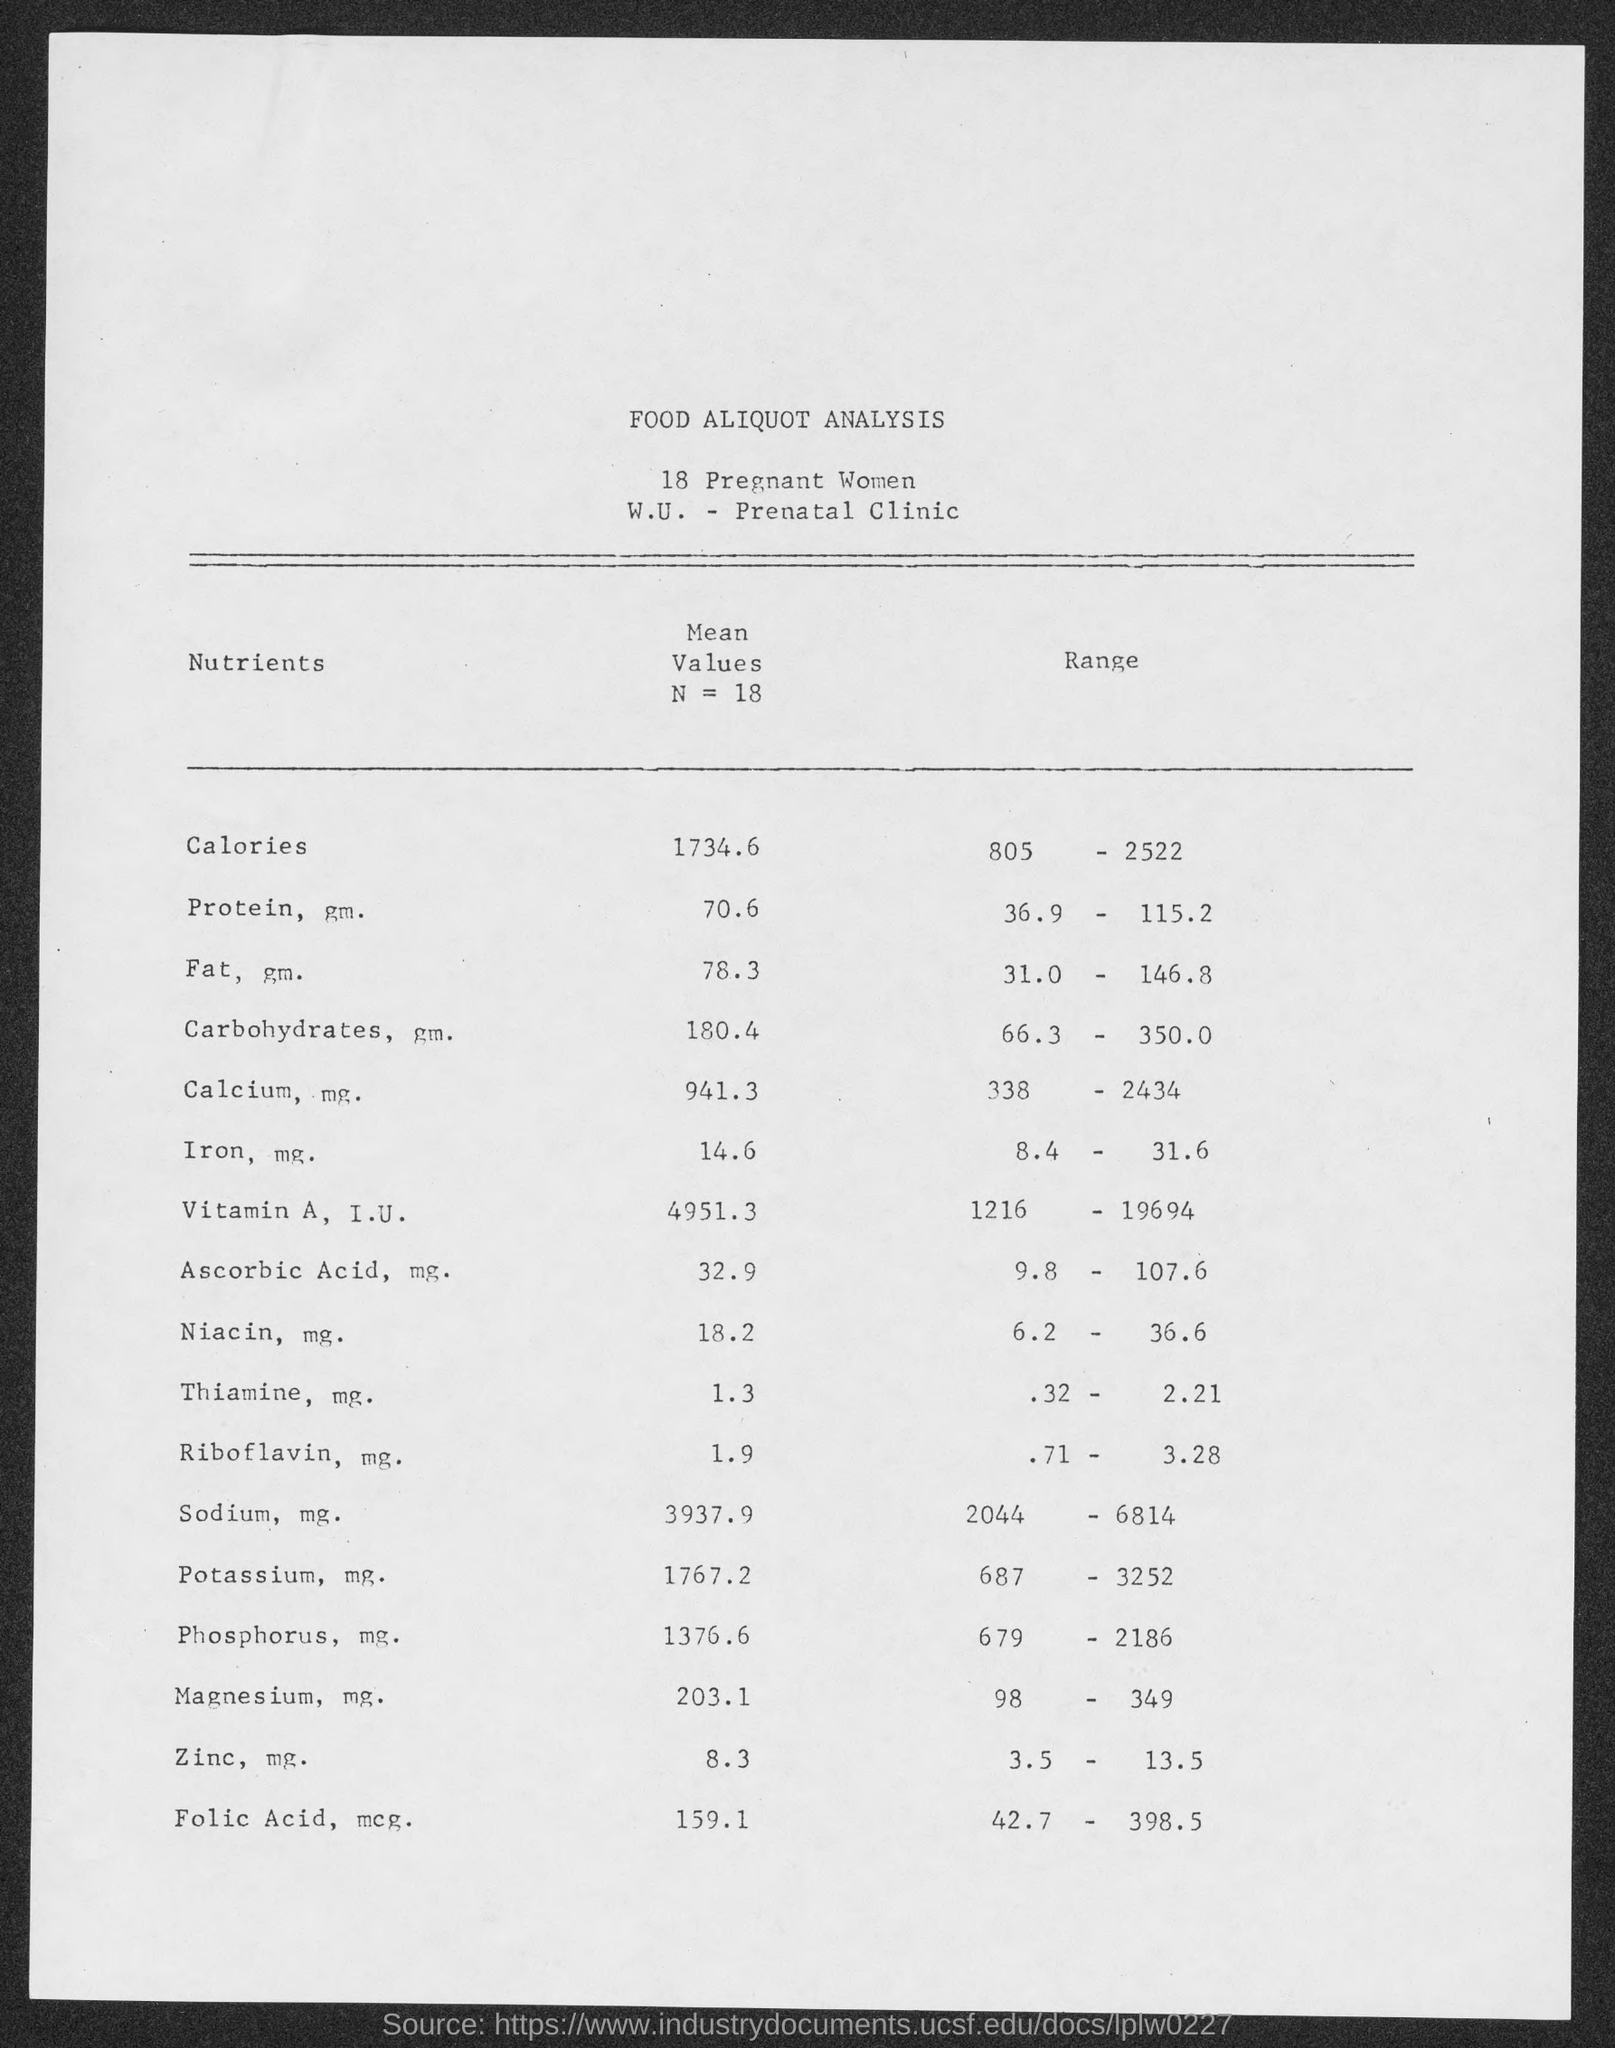Draw attention to some important aspects in this diagram. The mean value of Ascorbic Acid, in milligrams, is 32.9 for a sample size of 18. The mean value of iron in a sample of 18 measurements was 14.6 milligrams. The mean value of Riboflavin, in milligrams, for a sample of N=18 is 1.9 milligrams. The mean value for carbohydrates, in grams, is 180.4 when N is 18. The mean value of calcium, in milligrams, is 941.3 for a sample size of 18. 